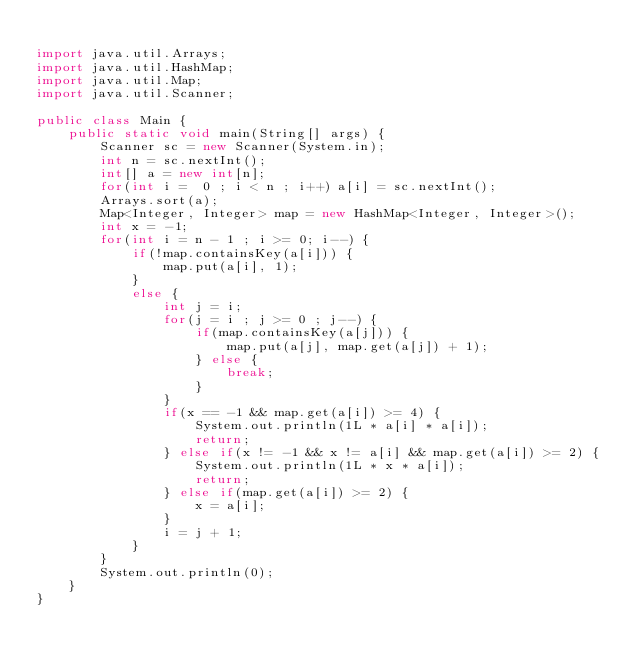<code> <loc_0><loc_0><loc_500><loc_500><_Java_>
import java.util.Arrays;
import java.util.HashMap;
import java.util.Map;
import java.util.Scanner;

public class Main {
	public static void main(String[] args) {
		Scanner sc = new Scanner(System.in);
		int n = sc.nextInt();
		int[] a = new int[n];
		for(int i =  0 ; i < n ; i++) a[i] = sc.nextInt();
		Arrays.sort(a);
		Map<Integer, Integer> map = new HashMap<Integer, Integer>();
		int x = -1;
		for(int i = n - 1 ; i >= 0; i--) {
			if(!map.containsKey(a[i])) {
				map.put(a[i], 1);
			}
			else {
				int j = i;
				for(j = i ; j >= 0 ; j--) {
					if(map.containsKey(a[j])) {
						map.put(a[j], map.get(a[j]) + 1);
					} else {
						break;
					}
				}
				if(x == -1 && map.get(a[i]) >= 4) {
					System.out.println(1L * a[i] * a[i]);
					return;
				} else if(x != -1 && x != a[i] && map.get(a[i]) >= 2) {
					System.out.println(1L * x * a[i]);
					return;
				} else if(map.get(a[i]) >= 2) {
					x = a[i];
				}
				i = j + 1;
			}
		}
		System.out.println(0);
	}
}</code> 